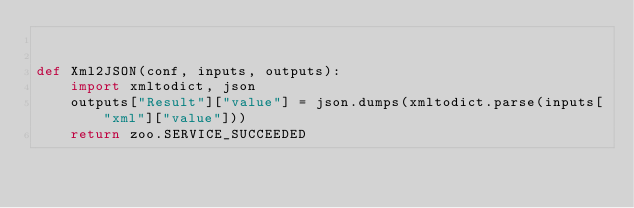<code> <loc_0><loc_0><loc_500><loc_500><_Python_>

def Xml2JSON(conf, inputs, outputs):
    import xmltodict, json
    outputs["Result"]["value"] = json.dumps(xmltodict.parse(inputs["xml"]["value"]))
    return zoo.SERVICE_SUCCEEDED
</code> 